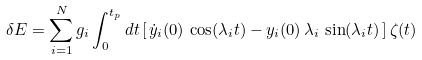Convert formula to latex. <formula><loc_0><loc_0><loc_500><loc_500>\delta E = \sum _ { i = 1 } ^ { N } g _ { i } \int _ { 0 } ^ { t _ { p } } d t \, [ \, \dot { y } _ { i } ( 0 ) \, \cos ( \lambda _ { i } t ) - y _ { i } ( 0 ) \, \lambda _ { i } \, \sin ( \lambda _ { i } t ) \, ] \, \zeta ( t )</formula> 